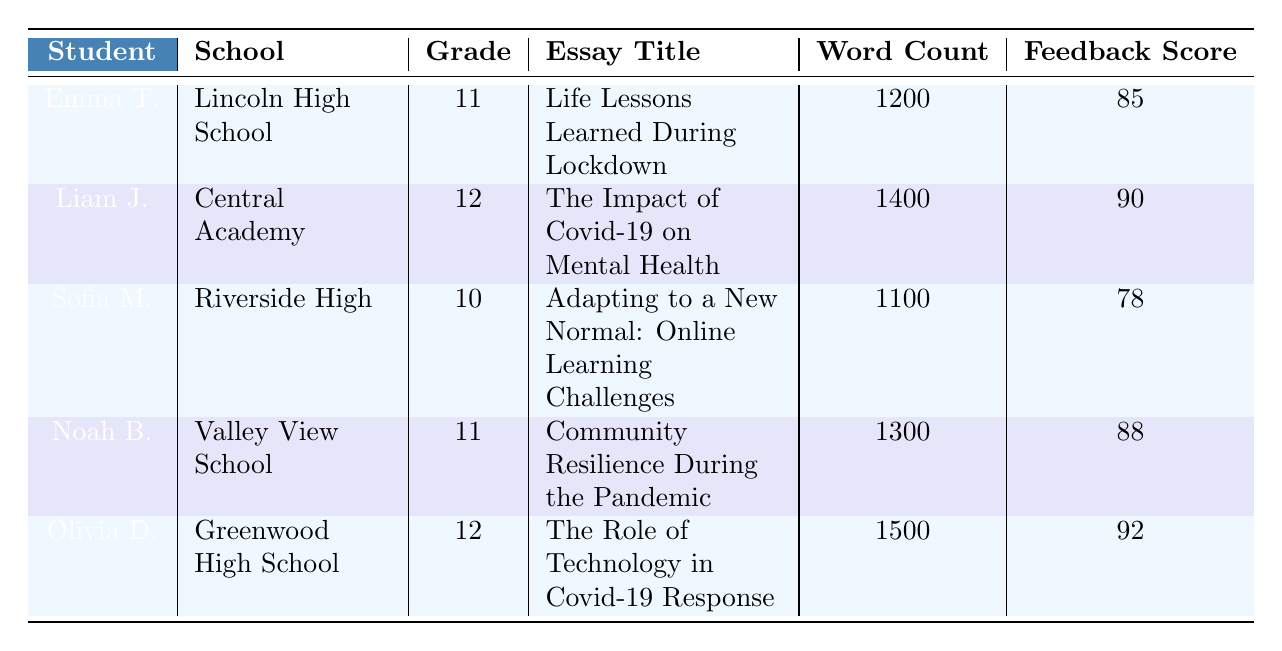What is the title of the essay submitted by Emma Thompson? To find the title of Emma Thompson's essay, locate her name in the table and read across to the corresponding essay title column. The title is "Life Lessons Learned During Lockdown."
Answer: Life Lessons Learned During Lockdown Which student had the highest feedback score? Review the feedback scores of all students. The scores are 85, 90, 78, 88, and 92. Olivia Davis has the highest score with 92.
Answer: Olivia Davis What is the average word count of the essays submitted? To find the average word count, sum the word counts: 1200 + 1400 + 1100 + 1300 + 1500 = 7300. There are 5 submissions, so divide the total by 5: 7300 / 5 = 1460.
Answer: 1460 Did Noah Brown's essay score above 85? Check Noah Brown's feedback score, which is 88. Since 88 is greater than 85, the answer is yes.
Answer: Yes Which school has the student with the lowest feedback score? Identify the lowest feedback score from the table, which is 78 (Sofia Martinez). Then check her school, which is Riverside High.
Answer: Riverside High What is the difference between the word count of Olivia Davis's essay and Sofia Martinez's essay? Find the word counts: Olivia Davis has 1500 words and Sofia Martinez has 1100 words. The difference is 1500 - 1100 = 400.
Answer: 400 How many students submitted essays on the topic of health and wellness? Look at the topic column to determine that only one student, Liam Johnson, submitted an essay on health and wellness.
Answer: 1 Is there a student in grade 10 who submitted an essay? Review the grade column and identify that Sofia Martinez is in grade 10 and did submit an essay.
Answer: Yes What is the total feedback score of students from grade 12? Identify the students in grade 12: Liam Johnson (90) and Olivia Davis (92). Their combined score is 90 + 92 = 182.
Answer: 182 